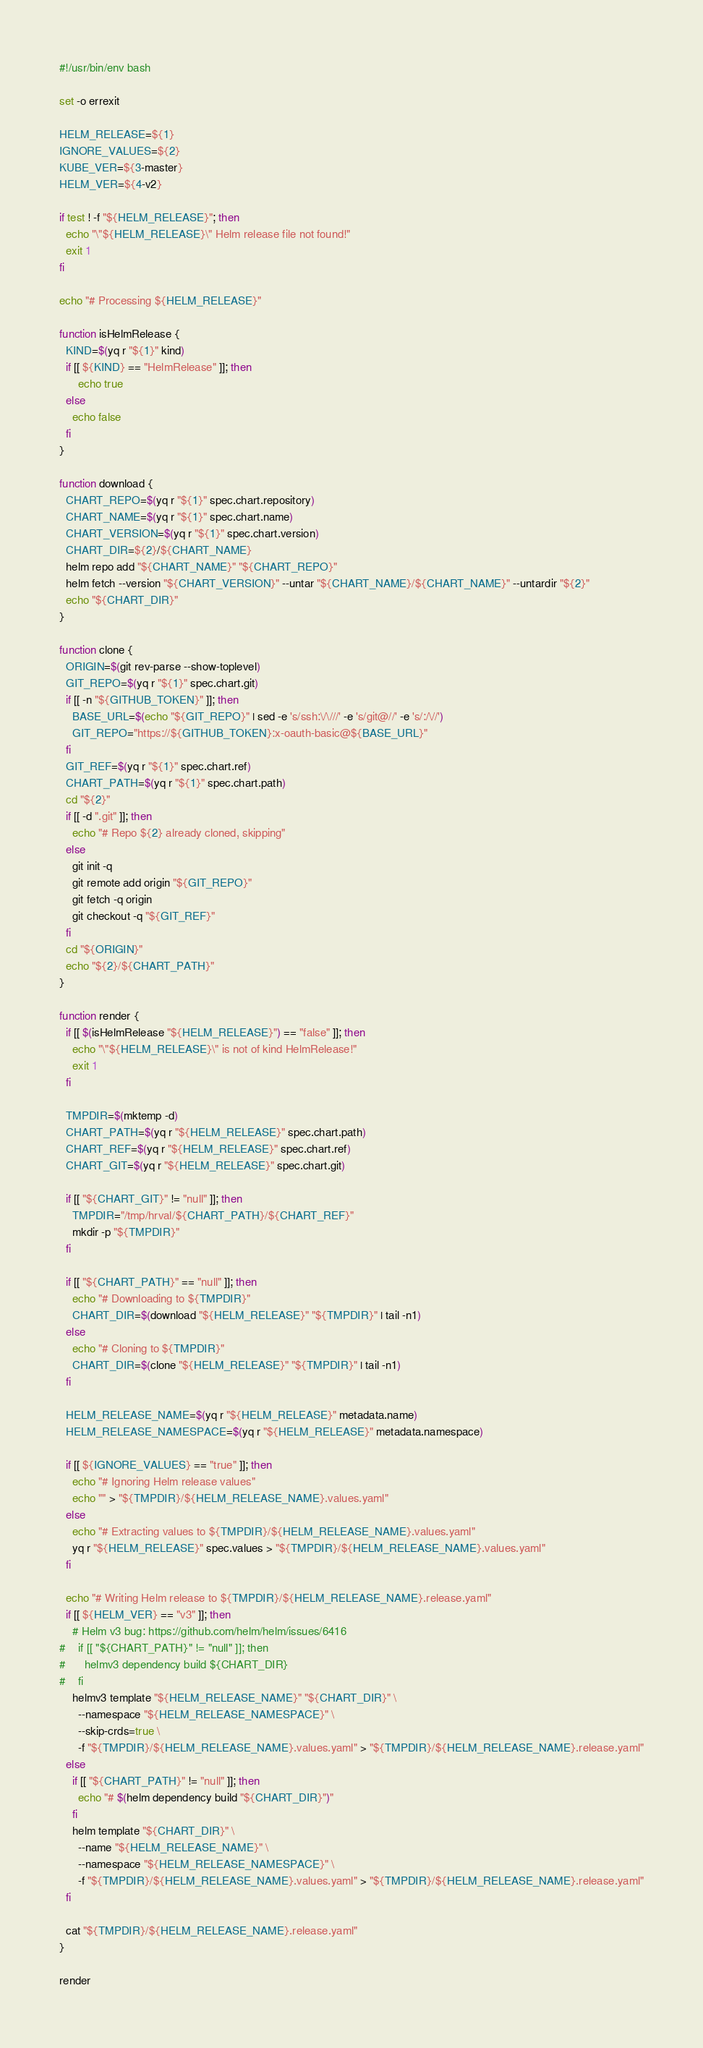Convert code to text. <code><loc_0><loc_0><loc_500><loc_500><_Bash_>#!/usr/bin/env bash

set -o errexit

HELM_RELEASE=${1}
IGNORE_VALUES=${2}
KUBE_VER=${3-master}
HELM_VER=${4-v2}

if test ! -f "${HELM_RELEASE}"; then
  echo "\"${HELM_RELEASE}\" Helm release file not found!"
  exit 1
fi

echo "# Processing ${HELM_RELEASE}"

function isHelmRelease {
  KIND=$(yq r "${1}" kind)
  if [[ ${KIND} == "HelmRelease" ]]; then
      echo true
  else
    echo false
  fi
}

function download {
  CHART_REPO=$(yq r "${1}" spec.chart.repository)
  CHART_NAME=$(yq r "${1}" spec.chart.name)
  CHART_VERSION=$(yq r "${1}" spec.chart.version)
  CHART_DIR=${2}/${CHART_NAME}
  helm repo add "${CHART_NAME}" "${CHART_REPO}"
  helm fetch --version "${CHART_VERSION}" --untar "${CHART_NAME}/${CHART_NAME}" --untardir "${2}"
  echo "${CHART_DIR}"
}

function clone {
  ORIGIN=$(git rev-parse --show-toplevel)
  GIT_REPO=$(yq r "${1}" spec.chart.git)
  if [[ -n "${GITHUB_TOKEN}" ]]; then
    BASE_URL=$(echo "${GIT_REPO}" | sed -e 's/ssh:\/\///' -e 's/git@//' -e 's/:/\//')
    GIT_REPO="https://${GITHUB_TOKEN}:x-oauth-basic@${BASE_URL}"
  fi
  GIT_REF=$(yq r "${1}" spec.chart.ref)
  CHART_PATH=$(yq r "${1}" spec.chart.path)
  cd "${2}"
  if [[ -d ".git" ]]; then
    echo "# Repo ${2} already cloned, skipping"
  else
    git init -q
    git remote add origin "${GIT_REPO}"
    git fetch -q origin
    git checkout -q "${GIT_REF}"
  fi
  cd "${ORIGIN}"
  echo "${2}/${CHART_PATH}"
}

function render {
  if [[ $(isHelmRelease "${HELM_RELEASE}") == "false" ]]; then
    echo "\"${HELM_RELEASE}\" is not of kind HelmRelease!"
    exit 1
  fi

  TMPDIR=$(mktemp -d)
  CHART_PATH=$(yq r "${HELM_RELEASE}" spec.chart.path)
  CHART_REF=$(yq r "${HELM_RELEASE}" spec.chart.ref)
  CHART_GIT=$(yq r "${HELM_RELEASE}" spec.chart.git)

  if [[ "${CHART_GIT}" != "null" ]]; then
    TMPDIR="/tmp/hrval/${CHART_PATH}/${CHART_REF}"
    mkdir -p "${TMPDIR}"
  fi

  if [[ "${CHART_PATH}" == "null" ]]; then
    echo "# Downloading to ${TMPDIR}"
    CHART_DIR=$(download "${HELM_RELEASE}" "${TMPDIR}" | tail -n1)
  else
    echo "# Cloning to ${TMPDIR}"
    CHART_DIR=$(clone "${HELM_RELEASE}" "${TMPDIR}" | tail -n1)
  fi

  HELM_RELEASE_NAME=$(yq r "${HELM_RELEASE}" metadata.name)
  HELM_RELEASE_NAMESPACE=$(yq r "${HELM_RELEASE}" metadata.namespace)

  if [[ ${IGNORE_VALUES} == "true" ]]; then
    echo "# Ignoring Helm release values"
    echo "" > "${TMPDIR}/${HELM_RELEASE_NAME}.values.yaml"
  else
    echo "# Extracting values to ${TMPDIR}/${HELM_RELEASE_NAME}.values.yaml"
    yq r "${HELM_RELEASE}" spec.values > "${TMPDIR}/${HELM_RELEASE_NAME}.values.yaml"
  fi

  echo "# Writing Helm release to ${TMPDIR}/${HELM_RELEASE_NAME}.release.yaml"
  if [[ ${HELM_VER} == "v3" ]]; then
    # Helm v3 bug: https://github.com/helm/helm/issues/6416
#    if [[ "${CHART_PATH}" != "null" ]]; then
#      helmv3 dependency build ${CHART_DIR}
#    fi
    helmv3 template "${HELM_RELEASE_NAME}" "${CHART_DIR}" \
      --namespace "${HELM_RELEASE_NAMESPACE}" \
      --skip-crds=true \
      -f "${TMPDIR}/${HELM_RELEASE_NAME}.values.yaml" > "${TMPDIR}/${HELM_RELEASE_NAME}.release.yaml"
  else
    if [[ "${CHART_PATH}" != "null" ]]; then
      echo "# $(helm dependency build "${CHART_DIR}")"
    fi
    helm template "${CHART_DIR}" \
      --name "${HELM_RELEASE_NAME}" \
      --namespace "${HELM_RELEASE_NAMESPACE}" \
      -f "${TMPDIR}/${HELM_RELEASE_NAME}.values.yaml" > "${TMPDIR}/${HELM_RELEASE_NAME}.release.yaml"
  fi

  cat "${TMPDIR}/${HELM_RELEASE_NAME}.release.yaml"
}

render
</code> 